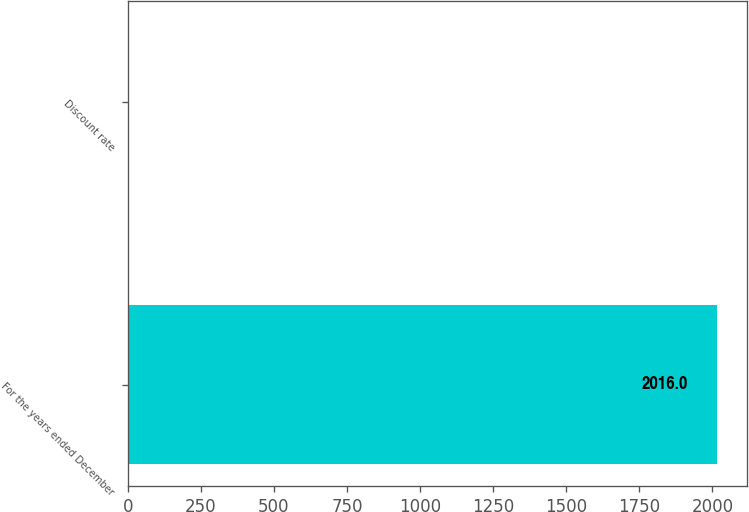Convert chart to OTSL. <chart><loc_0><loc_0><loc_500><loc_500><bar_chart><fcel>For the years ended December<fcel>Discount rate<nl><fcel>2016<fcel>3.9<nl></chart> 